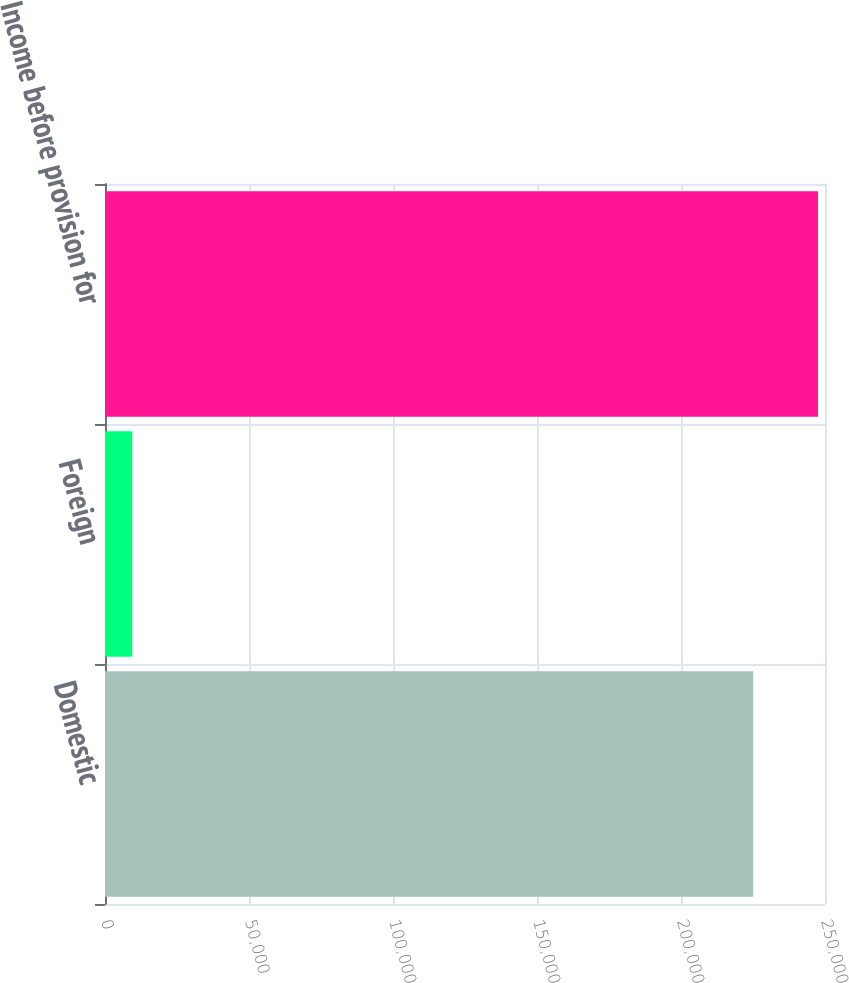<chart> <loc_0><loc_0><loc_500><loc_500><bar_chart><fcel>Domestic<fcel>Foreign<fcel>Income before provision for<nl><fcel>225079<fcel>9456<fcel>247587<nl></chart> 